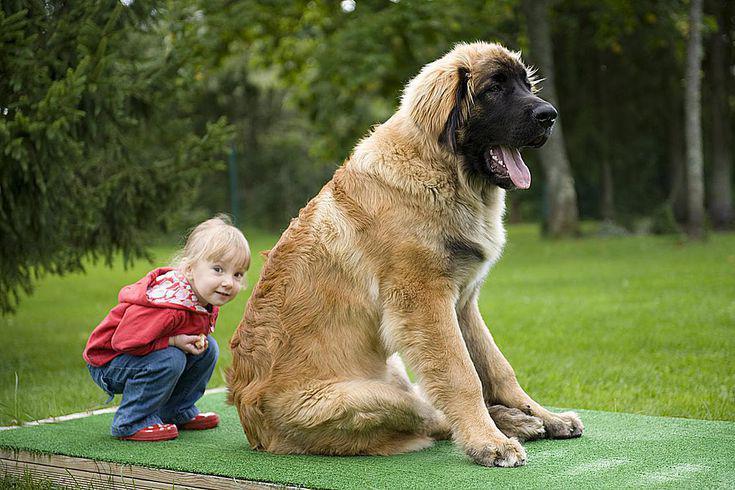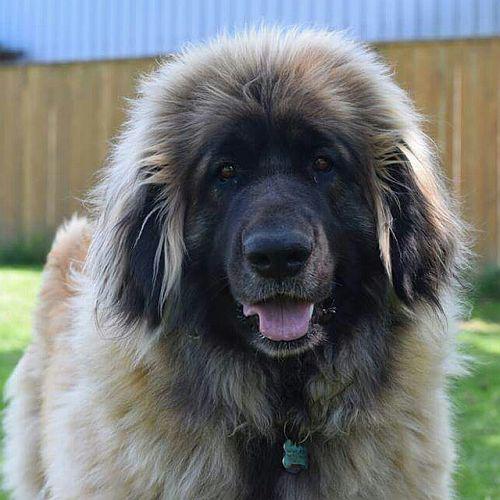The first image is the image on the left, the second image is the image on the right. For the images displayed, is the sentence "The dog in the left image is looking towards the right with its tongue hanging out." factually correct? Answer yes or no. Yes. 